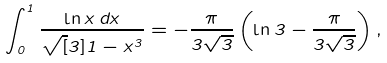<formula> <loc_0><loc_0><loc_500><loc_500>\int _ { 0 } ^ { 1 } \frac { \ln x \, d x } { \sqrt { [ } 3 ] { 1 - x ^ { 3 } } } = - \frac { \pi } { 3 \sqrt { 3 } } \left ( \ln 3 - \frac { \pi } { 3 \sqrt { 3 } } \right ) ,</formula> 